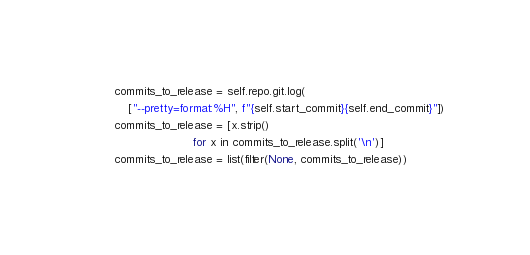Convert code to text. <code><loc_0><loc_0><loc_500><loc_500><_Python_>        commits_to_release = self.repo.git.log(
            ["--pretty=format:%H", f"{self.start_commit}{self.end_commit}"])
        commits_to_release = [x.strip()
                              for x in commits_to_release.split('\n')]
        commits_to_release = list(filter(None, commits_to_release))
</code> 